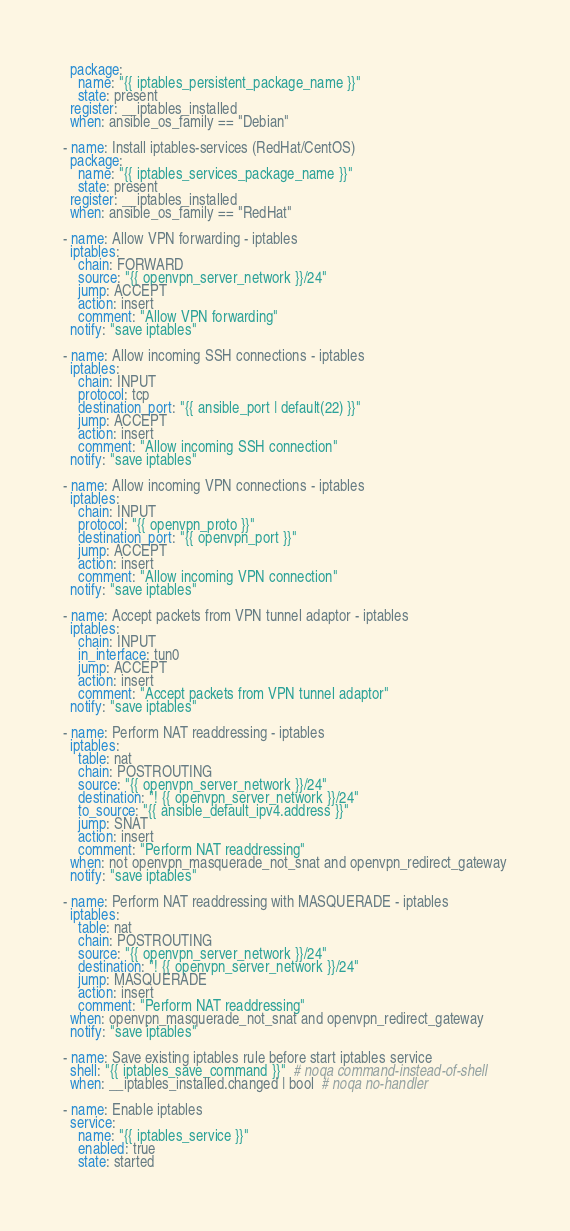<code> <loc_0><loc_0><loc_500><loc_500><_YAML_>  package:
    name: "{{ iptables_persistent_package_name }}"
    state: present
  register: __iptables_installed
  when: ansible_os_family == "Debian"

- name: Install iptables-services (RedHat/CentOS)
  package:
    name: "{{ iptables_services_package_name }}"
    state: present
  register: __iptables_installed
  when: ansible_os_family == "RedHat"

- name: Allow VPN forwarding - iptables
  iptables:
    chain: FORWARD
    source: "{{ openvpn_server_network }}/24"
    jump: ACCEPT
    action: insert
    comment: "Allow VPN forwarding"
  notify: "save iptables"

- name: Allow incoming SSH connections - iptables
  iptables:
    chain: INPUT
    protocol: tcp
    destination_port: "{{ ansible_port | default(22) }}"
    jump: ACCEPT
    action: insert
    comment: "Allow incoming SSH connection"
  notify: "save iptables"

- name: Allow incoming VPN connections - iptables
  iptables:
    chain: INPUT
    protocol: "{{ openvpn_proto }}"
    destination_port: "{{ openvpn_port }}"
    jump: ACCEPT
    action: insert
    comment: "Allow incoming VPN connection"
  notify: "save iptables"

- name: Accept packets from VPN tunnel adaptor - iptables
  iptables:
    chain: INPUT
    in_interface: tun0
    jump: ACCEPT
    action: insert
    comment: "Accept packets from VPN tunnel adaptor"
  notify: "save iptables"

- name: Perform NAT readdressing - iptables
  iptables:
    table: nat
    chain: POSTROUTING
    source: "{{ openvpn_server_network }}/24"
    destination: "! {{ openvpn_server_network }}/24"
    to_source: "{{ ansible_default_ipv4.address }}"
    jump: SNAT
    action: insert
    comment: "Perform NAT readdressing"
  when: not openvpn_masquerade_not_snat and openvpn_redirect_gateway
  notify: "save iptables"

- name: Perform NAT readdressing with MASQUERADE - iptables
  iptables:
    table: nat
    chain: POSTROUTING
    source: "{{ openvpn_server_network }}/24"
    destination: "! {{ openvpn_server_network }}/24"
    jump: MASQUERADE
    action: insert
    comment: "Perform NAT readdressing"
  when: openvpn_masquerade_not_snat and openvpn_redirect_gateway
  notify: "save iptables"

- name: Save existing iptables rule before start iptables service
  shell: "{{ iptables_save_command }}"  # noqa command-instead-of-shell
  when: __iptables_installed.changed | bool  # noqa no-handler

- name: Enable iptables
  service:
    name: "{{ iptables_service }}"
    enabled: true
    state: started
</code> 